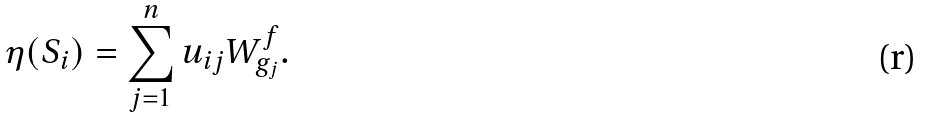Convert formula to latex. <formula><loc_0><loc_0><loc_500><loc_500>\eta ( S _ { i } ) = \sum _ { j = 1 } ^ { n } u _ { i j } W _ { g _ { j } } ^ { f } \text {.}</formula> 